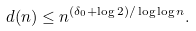Convert formula to latex. <formula><loc_0><loc_0><loc_500><loc_500>d ( n ) \leq n ^ { ( \delta _ { 0 } + \log 2 ) / \log \log n } .</formula> 